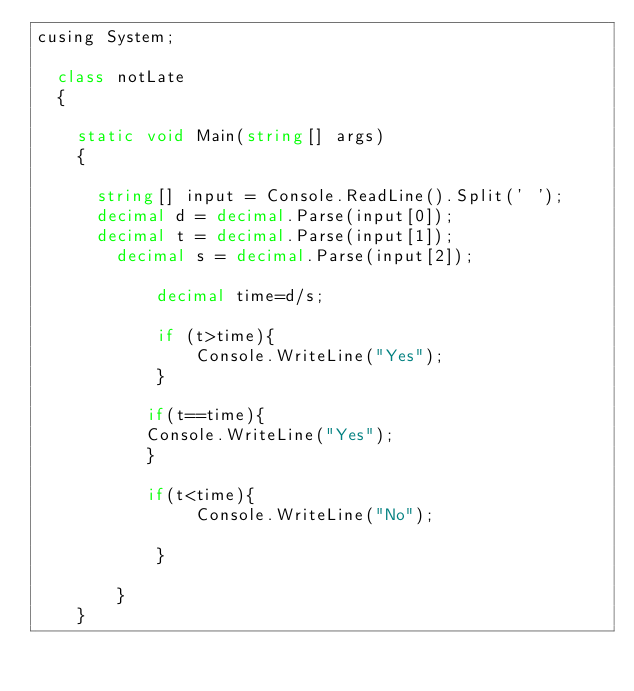<code> <loc_0><loc_0><loc_500><loc_500><_C#_>cusing System;
 
	class notLate
	{
 
		static void Main(string[] args)
		{
			
			string[] input = Console.ReadLine().Split(' ');
			decimal d = decimal.Parse(input[0]);
			decimal t = decimal.Parse(input[1]);
		    decimal s = decimal.Parse(input[2]);
            
            decimal time=d/s;

            if (t>time){
                Console.WriteLine("Yes");
            }
          
           if(t==time){
           Console.WriteLine("Yes");
           }
             
           if(t<time){
                Console.WriteLine("No");

            }

        }
    }</code> 